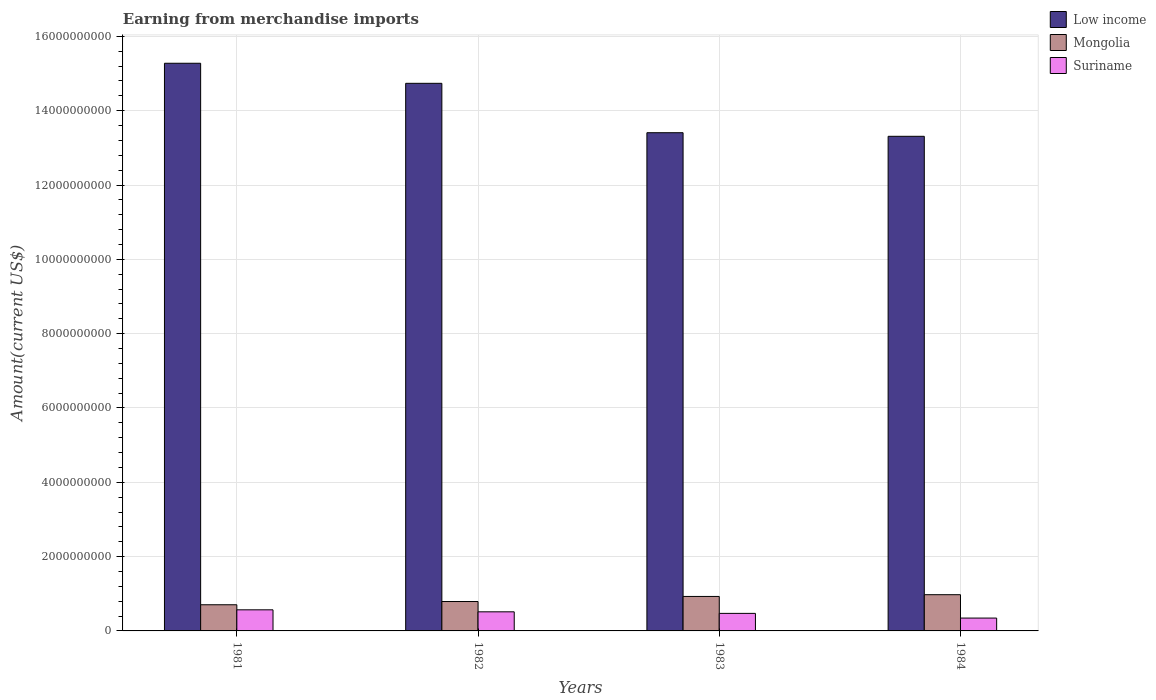How many different coloured bars are there?
Make the answer very short. 3. Are the number of bars per tick equal to the number of legend labels?
Provide a short and direct response. Yes. Are the number of bars on each tick of the X-axis equal?
Ensure brevity in your answer.  Yes. How many bars are there on the 4th tick from the right?
Make the answer very short. 3. In how many cases, is the number of bars for a given year not equal to the number of legend labels?
Give a very brief answer. 0. What is the amount earned from merchandise imports in Suriname in 1982?
Provide a short and direct response. 5.14e+08. Across all years, what is the maximum amount earned from merchandise imports in Mongolia?
Ensure brevity in your answer.  9.75e+08. Across all years, what is the minimum amount earned from merchandise imports in Suriname?
Offer a terse response. 3.46e+08. In which year was the amount earned from merchandise imports in Low income maximum?
Make the answer very short. 1981. What is the total amount earned from merchandise imports in Mongolia in the graph?
Give a very brief answer. 3.40e+09. What is the difference between the amount earned from merchandise imports in Low income in 1981 and that in 1982?
Provide a succinct answer. 5.40e+08. What is the difference between the amount earned from merchandise imports in Low income in 1982 and the amount earned from merchandise imports in Suriname in 1983?
Your answer should be compact. 1.43e+1. What is the average amount earned from merchandise imports in Mongolia per year?
Ensure brevity in your answer.  8.50e+08. In the year 1983, what is the difference between the amount earned from merchandise imports in Suriname and amount earned from merchandise imports in Low income?
Offer a terse response. -1.29e+1. In how many years, is the amount earned from merchandise imports in Mongolia greater than 400000000 US$?
Your response must be concise. 4. What is the ratio of the amount earned from merchandise imports in Low income in 1983 to that in 1984?
Provide a short and direct response. 1.01. Is the amount earned from merchandise imports in Low income in 1981 less than that in 1983?
Give a very brief answer. No. What is the difference between the highest and the second highest amount earned from merchandise imports in Suriname?
Provide a short and direct response. 5.40e+07. What is the difference between the highest and the lowest amount earned from merchandise imports in Low income?
Provide a succinct answer. 1.97e+09. In how many years, is the amount earned from merchandise imports in Suriname greater than the average amount earned from merchandise imports in Suriname taken over all years?
Make the answer very short. 2. Is the sum of the amount earned from merchandise imports in Low income in 1983 and 1984 greater than the maximum amount earned from merchandise imports in Mongolia across all years?
Provide a succinct answer. Yes. What does the 3rd bar from the left in 1982 represents?
Offer a very short reply. Suriname. What does the 1st bar from the right in 1983 represents?
Give a very brief answer. Suriname. Are all the bars in the graph horizontal?
Your answer should be very brief. No. Are the values on the major ticks of Y-axis written in scientific E-notation?
Offer a terse response. No. Where does the legend appear in the graph?
Make the answer very short. Top right. What is the title of the graph?
Offer a very short reply. Earning from merchandise imports. Does "Qatar" appear as one of the legend labels in the graph?
Provide a succinct answer. No. What is the label or title of the X-axis?
Your answer should be compact. Years. What is the label or title of the Y-axis?
Keep it short and to the point. Amount(current US$). What is the Amount(current US$) in Low income in 1981?
Make the answer very short. 1.53e+1. What is the Amount(current US$) of Mongolia in 1981?
Your response must be concise. 7.04e+08. What is the Amount(current US$) of Suriname in 1981?
Offer a terse response. 5.68e+08. What is the Amount(current US$) of Low income in 1982?
Provide a short and direct response. 1.47e+1. What is the Amount(current US$) of Mongolia in 1982?
Give a very brief answer. 7.91e+08. What is the Amount(current US$) of Suriname in 1982?
Your response must be concise. 5.14e+08. What is the Amount(current US$) in Low income in 1983?
Give a very brief answer. 1.34e+1. What is the Amount(current US$) in Mongolia in 1983?
Give a very brief answer. 9.28e+08. What is the Amount(current US$) of Suriname in 1983?
Make the answer very short. 4.72e+08. What is the Amount(current US$) in Low income in 1984?
Offer a terse response. 1.33e+1. What is the Amount(current US$) of Mongolia in 1984?
Ensure brevity in your answer.  9.75e+08. What is the Amount(current US$) in Suriname in 1984?
Offer a very short reply. 3.46e+08. Across all years, what is the maximum Amount(current US$) of Low income?
Offer a terse response. 1.53e+1. Across all years, what is the maximum Amount(current US$) of Mongolia?
Make the answer very short. 9.75e+08. Across all years, what is the maximum Amount(current US$) of Suriname?
Give a very brief answer. 5.68e+08. Across all years, what is the minimum Amount(current US$) in Low income?
Keep it short and to the point. 1.33e+1. Across all years, what is the minimum Amount(current US$) of Mongolia?
Provide a succinct answer. 7.04e+08. Across all years, what is the minimum Amount(current US$) in Suriname?
Ensure brevity in your answer.  3.46e+08. What is the total Amount(current US$) in Low income in the graph?
Keep it short and to the point. 5.67e+1. What is the total Amount(current US$) in Mongolia in the graph?
Your answer should be very brief. 3.40e+09. What is the total Amount(current US$) of Suriname in the graph?
Provide a short and direct response. 1.90e+09. What is the difference between the Amount(current US$) in Low income in 1981 and that in 1982?
Keep it short and to the point. 5.40e+08. What is the difference between the Amount(current US$) in Mongolia in 1981 and that in 1982?
Your answer should be compact. -8.70e+07. What is the difference between the Amount(current US$) of Suriname in 1981 and that in 1982?
Your answer should be compact. 5.40e+07. What is the difference between the Amount(current US$) of Low income in 1981 and that in 1983?
Your answer should be compact. 1.87e+09. What is the difference between the Amount(current US$) of Mongolia in 1981 and that in 1983?
Give a very brief answer. -2.24e+08. What is the difference between the Amount(current US$) of Suriname in 1981 and that in 1983?
Your answer should be compact. 9.60e+07. What is the difference between the Amount(current US$) of Low income in 1981 and that in 1984?
Your answer should be compact. 1.97e+09. What is the difference between the Amount(current US$) of Mongolia in 1981 and that in 1984?
Your answer should be compact. -2.71e+08. What is the difference between the Amount(current US$) in Suriname in 1981 and that in 1984?
Your answer should be compact. 2.22e+08. What is the difference between the Amount(current US$) in Low income in 1982 and that in 1983?
Ensure brevity in your answer.  1.33e+09. What is the difference between the Amount(current US$) in Mongolia in 1982 and that in 1983?
Offer a very short reply. -1.37e+08. What is the difference between the Amount(current US$) in Suriname in 1982 and that in 1983?
Your answer should be compact. 4.20e+07. What is the difference between the Amount(current US$) of Low income in 1982 and that in 1984?
Your answer should be compact. 1.43e+09. What is the difference between the Amount(current US$) in Mongolia in 1982 and that in 1984?
Give a very brief answer. -1.84e+08. What is the difference between the Amount(current US$) in Suriname in 1982 and that in 1984?
Ensure brevity in your answer.  1.68e+08. What is the difference between the Amount(current US$) of Low income in 1983 and that in 1984?
Offer a very short reply. 9.67e+07. What is the difference between the Amount(current US$) of Mongolia in 1983 and that in 1984?
Keep it short and to the point. -4.70e+07. What is the difference between the Amount(current US$) of Suriname in 1983 and that in 1984?
Make the answer very short. 1.26e+08. What is the difference between the Amount(current US$) in Low income in 1981 and the Amount(current US$) in Mongolia in 1982?
Offer a terse response. 1.45e+1. What is the difference between the Amount(current US$) of Low income in 1981 and the Amount(current US$) of Suriname in 1982?
Your response must be concise. 1.48e+1. What is the difference between the Amount(current US$) of Mongolia in 1981 and the Amount(current US$) of Suriname in 1982?
Make the answer very short. 1.90e+08. What is the difference between the Amount(current US$) in Low income in 1981 and the Amount(current US$) in Mongolia in 1983?
Provide a succinct answer. 1.43e+1. What is the difference between the Amount(current US$) in Low income in 1981 and the Amount(current US$) in Suriname in 1983?
Offer a very short reply. 1.48e+1. What is the difference between the Amount(current US$) of Mongolia in 1981 and the Amount(current US$) of Suriname in 1983?
Make the answer very short. 2.32e+08. What is the difference between the Amount(current US$) in Low income in 1981 and the Amount(current US$) in Mongolia in 1984?
Offer a terse response. 1.43e+1. What is the difference between the Amount(current US$) in Low income in 1981 and the Amount(current US$) in Suriname in 1984?
Your answer should be compact. 1.49e+1. What is the difference between the Amount(current US$) of Mongolia in 1981 and the Amount(current US$) of Suriname in 1984?
Offer a terse response. 3.58e+08. What is the difference between the Amount(current US$) in Low income in 1982 and the Amount(current US$) in Mongolia in 1983?
Your answer should be compact. 1.38e+1. What is the difference between the Amount(current US$) of Low income in 1982 and the Amount(current US$) of Suriname in 1983?
Provide a short and direct response. 1.43e+1. What is the difference between the Amount(current US$) in Mongolia in 1982 and the Amount(current US$) in Suriname in 1983?
Give a very brief answer. 3.19e+08. What is the difference between the Amount(current US$) in Low income in 1982 and the Amount(current US$) in Mongolia in 1984?
Ensure brevity in your answer.  1.38e+1. What is the difference between the Amount(current US$) in Low income in 1982 and the Amount(current US$) in Suriname in 1984?
Provide a succinct answer. 1.44e+1. What is the difference between the Amount(current US$) in Mongolia in 1982 and the Amount(current US$) in Suriname in 1984?
Give a very brief answer. 4.45e+08. What is the difference between the Amount(current US$) in Low income in 1983 and the Amount(current US$) in Mongolia in 1984?
Ensure brevity in your answer.  1.24e+1. What is the difference between the Amount(current US$) in Low income in 1983 and the Amount(current US$) in Suriname in 1984?
Your response must be concise. 1.31e+1. What is the difference between the Amount(current US$) of Mongolia in 1983 and the Amount(current US$) of Suriname in 1984?
Your response must be concise. 5.82e+08. What is the average Amount(current US$) in Low income per year?
Provide a succinct answer. 1.42e+1. What is the average Amount(current US$) in Mongolia per year?
Keep it short and to the point. 8.50e+08. What is the average Amount(current US$) of Suriname per year?
Keep it short and to the point. 4.75e+08. In the year 1981, what is the difference between the Amount(current US$) in Low income and Amount(current US$) in Mongolia?
Offer a very short reply. 1.46e+1. In the year 1981, what is the difference between the Amount(current US$) of Low income and Amount(current US$) of Suriname?
Provide a succinct answer. 1.47e+1. In the year 1981, what is the difference between the Amount(current US$) of Mongolia and Amount(current US$) of Suriname?
Your response must be concise. 1.36e+08. In the year 1982, what is the difference between the Amount(current US$) of Low income and Amount(current US$) of Mongolia?
Your answer should be compact. 1.39e+1. In the year 1982, what is the difference between the Amount(current US$) in Low income and Amount(current US$) in Suriname?
Provide a short and direct response. 1.42e+1. In the year 1982, what is the difference between the Amount(current US$) of Mongolia and Amount(current US$) of Suriname?
Give a very brief answer. 2.77e+08. In the year 1983, what is the difference between the Amount(current US$) of Low income and Amount(current US$) of Mongolia?
Make the answer very short. 1.25e+1. In the year 1983, what is the difference between the Amount(current US$) of Low income and Amount(current US$) of Suriname?
Provide a succinct answer. 1.29e+1. In the year 1983, what is the difference between the Amount(current US$) of Mongolia and Amount(current US$) of Suriname?
Keep it short and to the point. 4.56e+08. In the year 1984, what is the difference between the Amount(current US$) of Low income and Amount(current US$) of Mongolia?
Offer a very short reply. 1.23e+1. In the year 1984, what is the difference between the Amount(current US$) in Low income and Amount(current US$) in Suriname?
Your answer should be very brief. 1.30e+1. In the year 1984, what is the difference between the Amount(current US$) of Mongolia and Amount(current US$) of Suriname?
Provide a succinct answer. 6.29e+08. What is the ratio of the Amount(current US$) in Low income in 1981 to that in 1982?
Offer a very short reply. 1.04. What is the ratio of the Amount(current US$) of Mongolia in 1981 to that in 1982?
Offer a very short reply. 0.89. What is the ratio of the Amount(current US$) of Suriname in 1981 to that in 1982?
Provide a succinct answer. 1.11. What is the ratio of the Amount(current US$) in Low income in 1981 to that in 1983?
Offer a terse response. 1.14. What is the ratio of the Amount(current US$) in Mongolia in 1981 to that in 1983?
Keep it short and to the point. 0.76. What is the ratio of the Amount(current US$) in Suriname in 1981 to that in 1983?
Keep it short and to the point. 1.2. What is the ratio of the Amount(current US$) in Low income in 1981 to that in 1984?
Offer a terse response. 1.15. What is the ratio of the Amount(current US$) in Mongolia in 1981 to that in 1984?
Ensure brevity in your answer.  0.72. What is the ratio of the Amount(current US$) of Suriname in 1981 to that in 1984?
Ensure brevity in your answer.  1.64. What is the ratio of the Amount(current US$) of Low income in 1982 to that in 1983?
Provide a short and direct response. 1.1. What is the ratio of the Amount(current US$) of Mongolia in 1982 to that in 1983?
Ensure brevity in your answer.  0.85. What is the ratio of the Amount(current US$) of Suriname in 1982 to that in 1983?
Your response must be concise. 1.09. What is the ratio of the Amount(current US$) in Low income in 1982 to that in 1984?
Provide a succinct answer. 1.11. What is the ratio of the Amount(current US$) in Mongolia in 1982 to that in 1984?
Offer a very short reply. 0.81. What is the ratio of the Amount(current US$) in Suriname in 1982 to that in 1984?
Provide a succinct answer. 1.49. What is the ratio of the Amount(current US$) of Low income in 1983 to that in 1984?
Offer a terse response. 1.01. What is the ratio of the Amount(current US$) of Mongolia in 1983 to that in 1984?
Make the answer very short. 0.95. What is the ratio of the Amount(current US$) of Suriname in 1983 to that in 1984?
Provide a succinct answer. 1.36. What is the difference between the highest and the second highest Amount(current US$) of Low income?
Offer a terse response. 5.40e+08. What is the difference between the highest and the second highest Amount(current US$) of Mongolia?
Offer a terse response. 4.70e+07. What is the difference between the highest and the second highest Amount(current US$) in Suriname?
Provide a short and direct response. 5.40e+07. What is the difference between the highest and the lowest Amount(current US$) of Low income?
Your answer should be compact. 1.97e+09. What is the difference between the highest and the lowest Amount(current US$) of Mongolia?
Your answer should be compact. 2.71e+08. What is the difference between the highest and the lowest Amount(current US$) in Suriname?
Ensure brevity in your answer.  2.22e+08. 